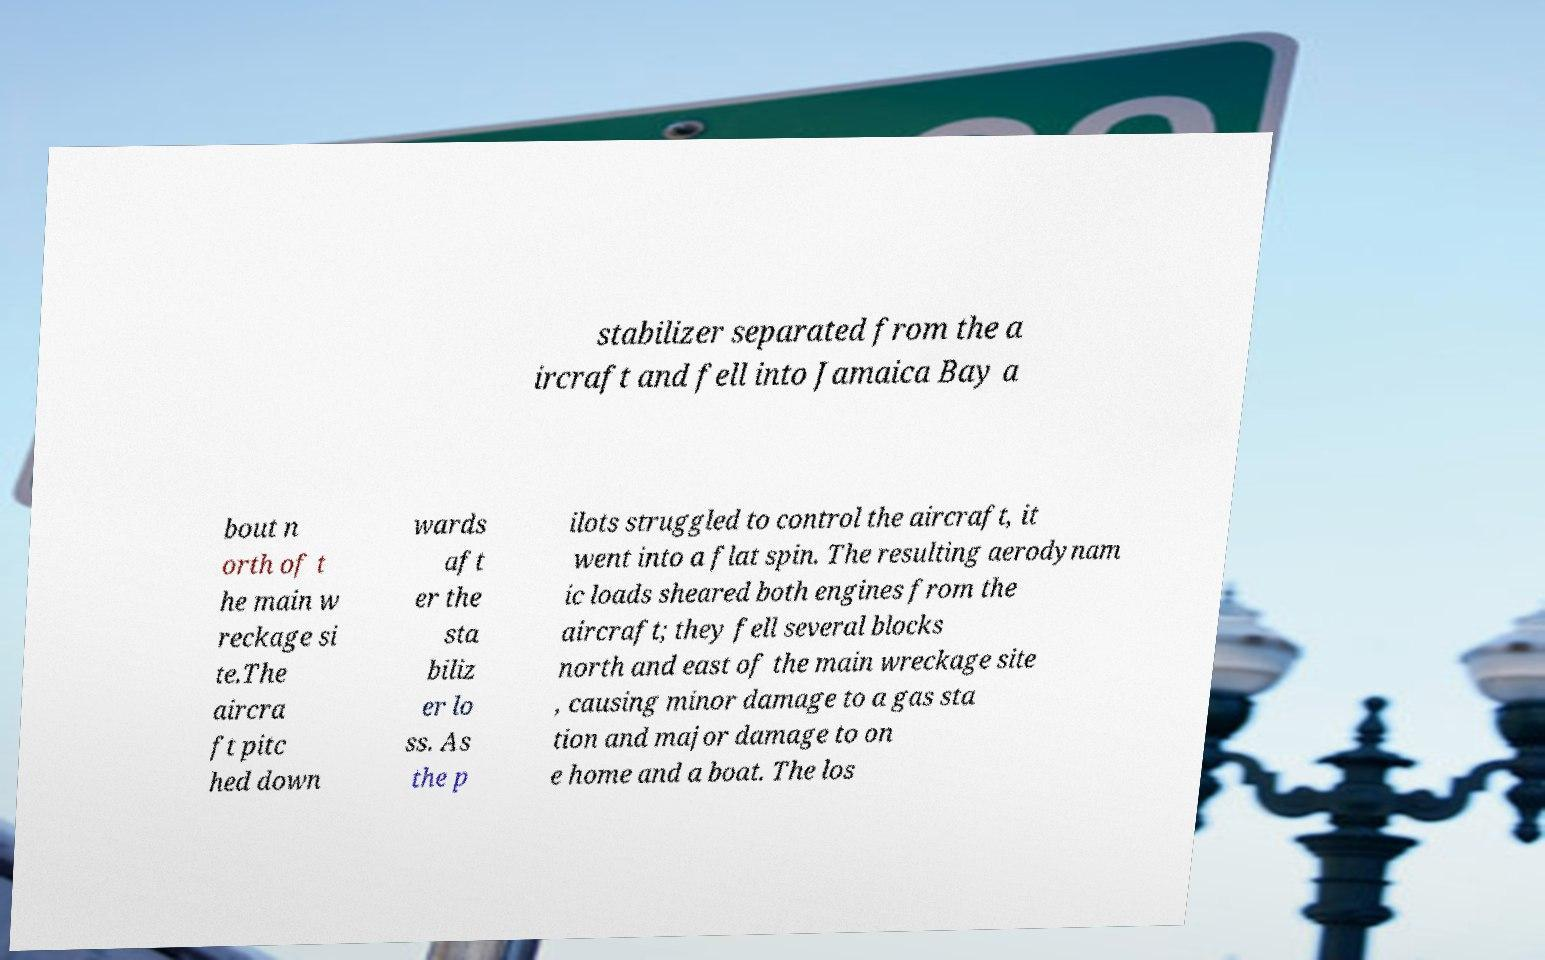Can you accurately transcribe the text from the provided image for me? stabilizer separated from the a ircraft and fell into Jamaica Bay a bout n orth of t he main w reckage si te.The aircra ft pitc hed down wards aft er the sta biliz er lo ss. As the p ilots struggled to control the aircraft, it went into a flat spin. The resulting aerodynam ic loads sheared both engines from the aircraft; they fell several blocks north and east of the main wreckage site , causing minor damage to a gas sta tion and major damage to on e home and a boat. The los 